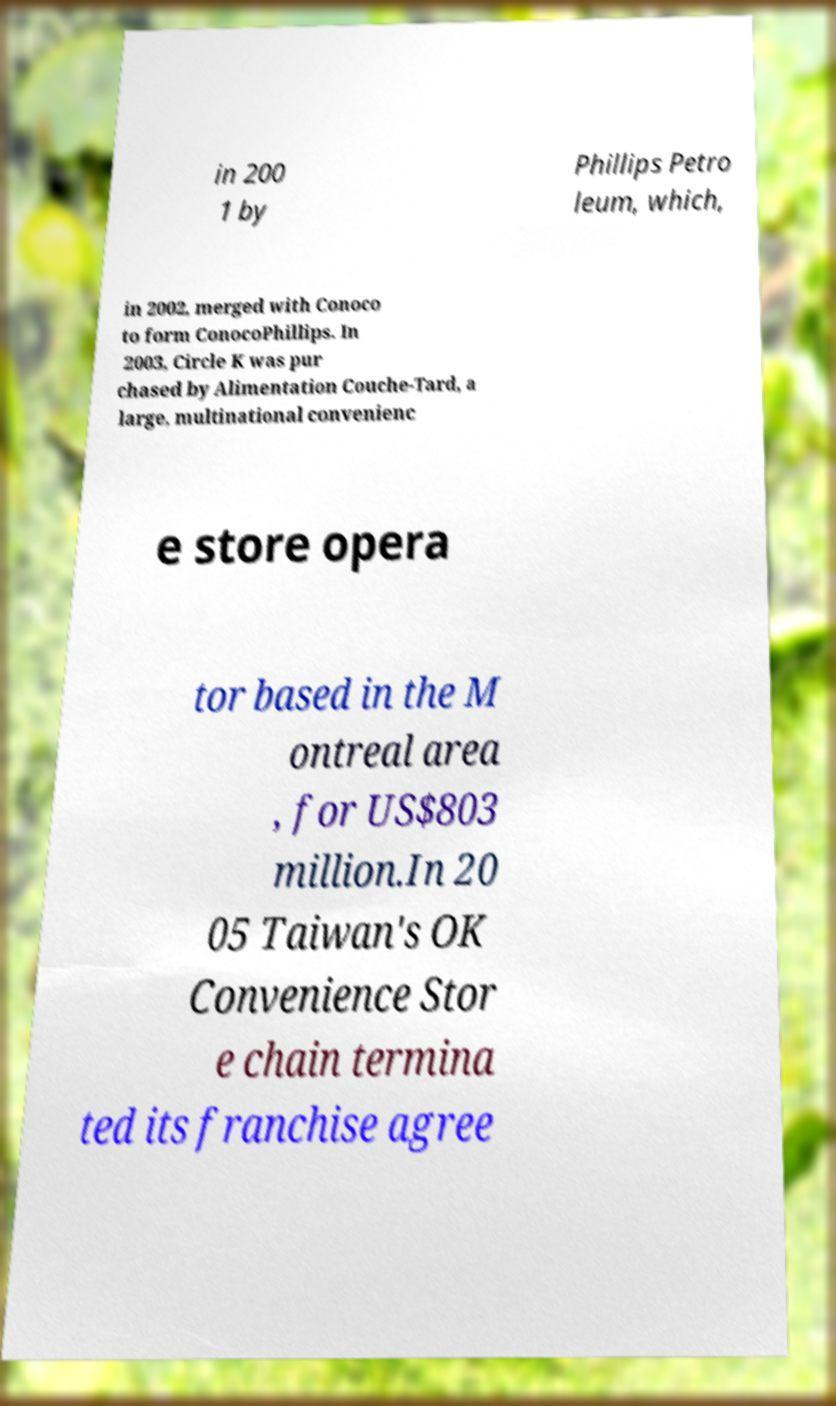Could you assist in decoding the text presented in this image and type it out clearly? in 200 1 by Phillips Petro leum, which, in 2002, merged with Conoco to form ConocoPhillips. In 2003, Circle K was pur chased by Alimentation Couche-Tard, a large, multinational convenienc e store opera tor based in the M ontreal area , for US$803 million.In 20 05 Taiwan's OK Convenience Stor e chain termina ted its franchise agree 